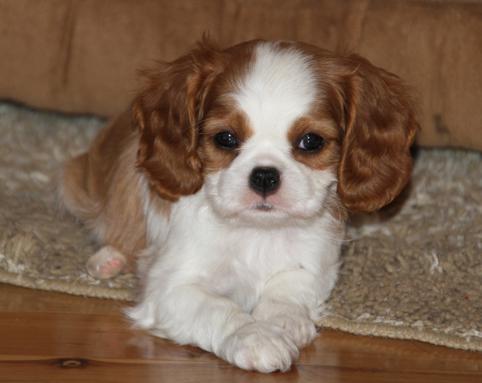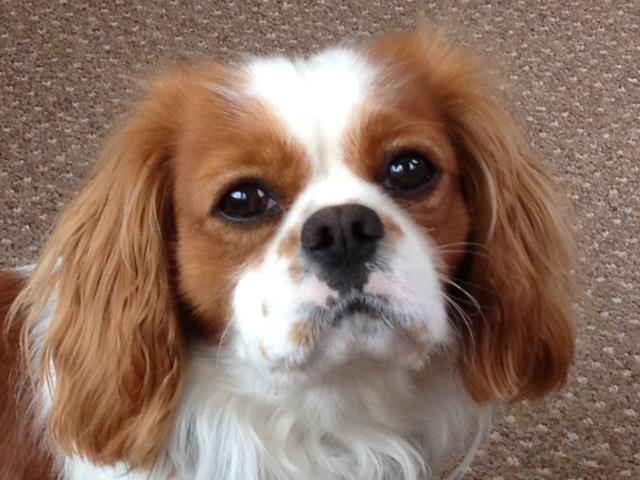The first image is the image on the left, the second image is the image on the right. Evaluate the accuracy of this statement regarding the images: "One of the images shows one dog on grass.". Is it true? Answer yes or no. No. The first image is the image on the left, the second image is the image on the right. For the images shown, is this caption "An image shows one spaniel posed on green grass." true? Answer yes or no. No. The first image is the image on the left, the second image is the image on the right. Assess this claim about the two images: "There is a single dog on grass in one of the images.". Correct or not? Answer yes or no. No. The first image is the image on the left, the second image is the image on the right. Considering the images on both sides, is "An image shows just one dog on green grass." valid? Answer yes or no. No. 